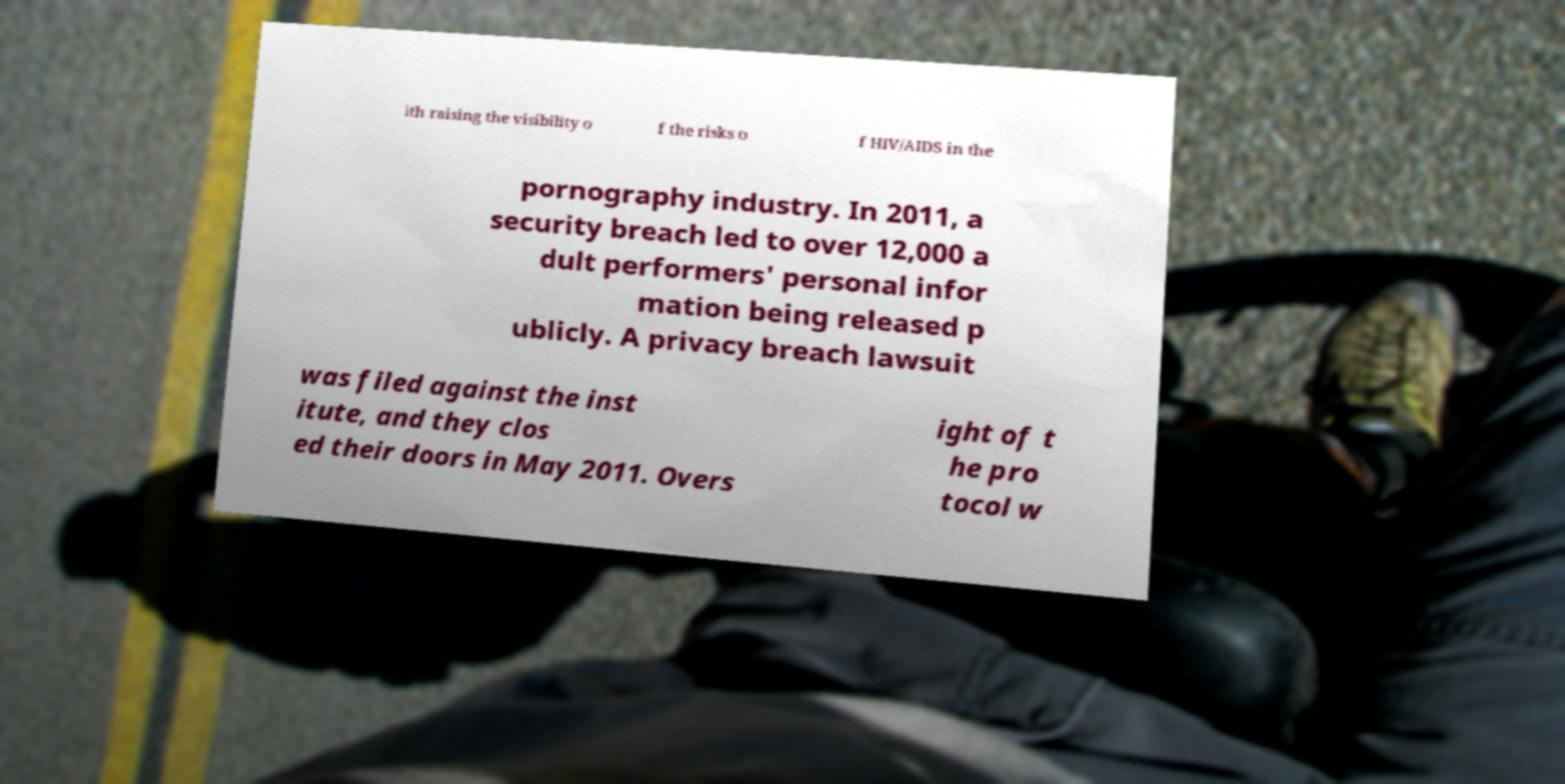Please read and relay the text visible in this image. What does it say? ith raising the visibility o f the risks o f HIV/AIDS in the pornography industry. In 2011, a security breach led to over 12,000 a dult performers' personal infor mation being released p ublicly. A privacy breach lawsuit was filed against the inst itute, and they clos ed their doors in May 2011. Overs ight of t he pro tocol w 